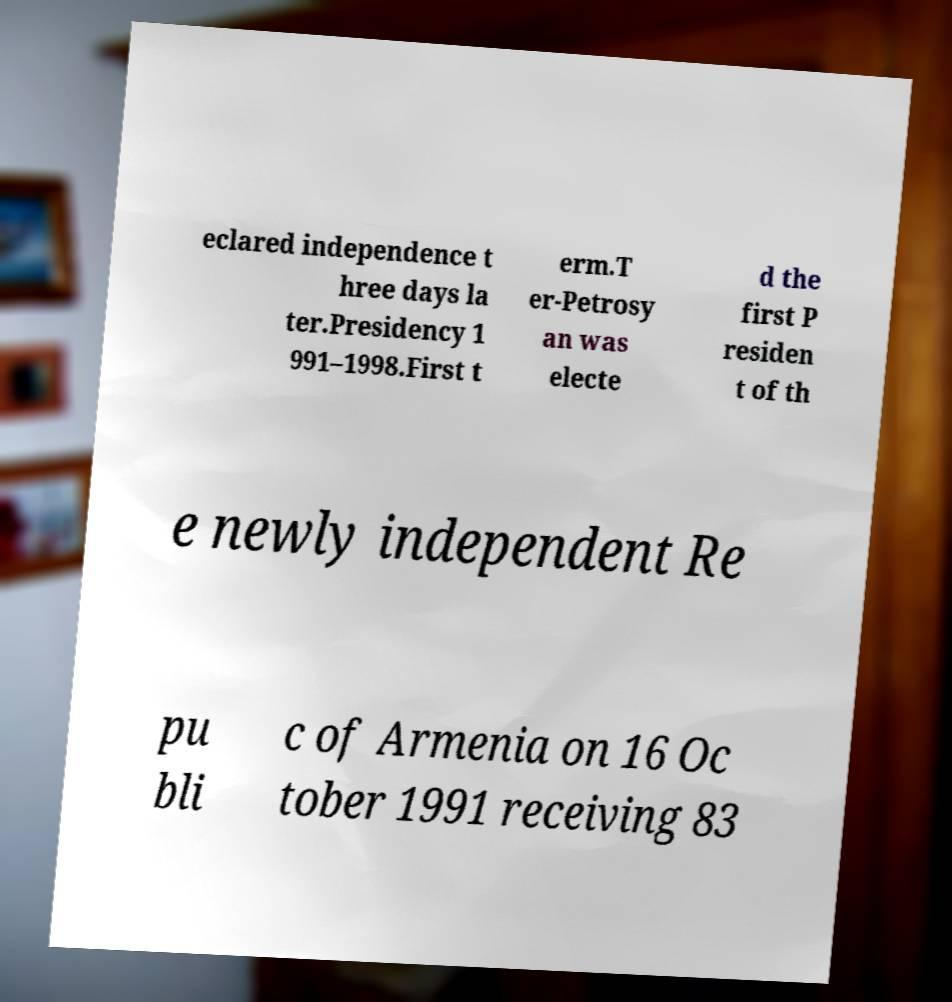What messages or text are displayed in this image? I need them in a readable, typed format. eclared independence t hree days la ter.Presidency 1 991–1998.First t erm.T er-Petrosy an was electe d the first P residen t of th e newly independent Re pu bli c of Armenia on 16 Oc tober 1991 receiving 83 